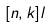Convert formula to latex. <formula><loc_0><loc_0><loc_500><loc_500>[ n , k ] l</formula> 